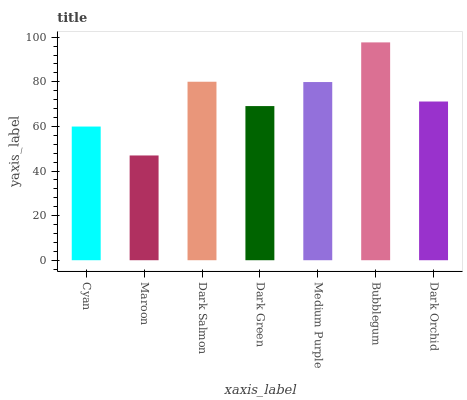Is Maroon the minimum?
Answer yes or no. Yes. Is Bubblegum the maximum?
Answer yes or no. Yes. Is Dark Salmon the minimum?
Answer yes or no. No. Is Dark Salmon the maximum?
Answer yes or no. No. Is Dark Salmon greater than Maroon?
Answer yes or no. Yes. Is Maroon less than Dark Salmon?
Answer yes or no. Yes. Is Maroon greater than Dark Salmon?
Answer yes or no. No. Is Dark Salmon less than Maroon?
Answer yes or no. No. Is Dark Orchid the high median?
Answer yes or no. Yes. Is Dark Orchid the low median?
Answer yes or no. Yes. Is Dark Green the high median?
Answer yes or no. No. Is Dark Salmon the low median?
Answer yes or no. No. 